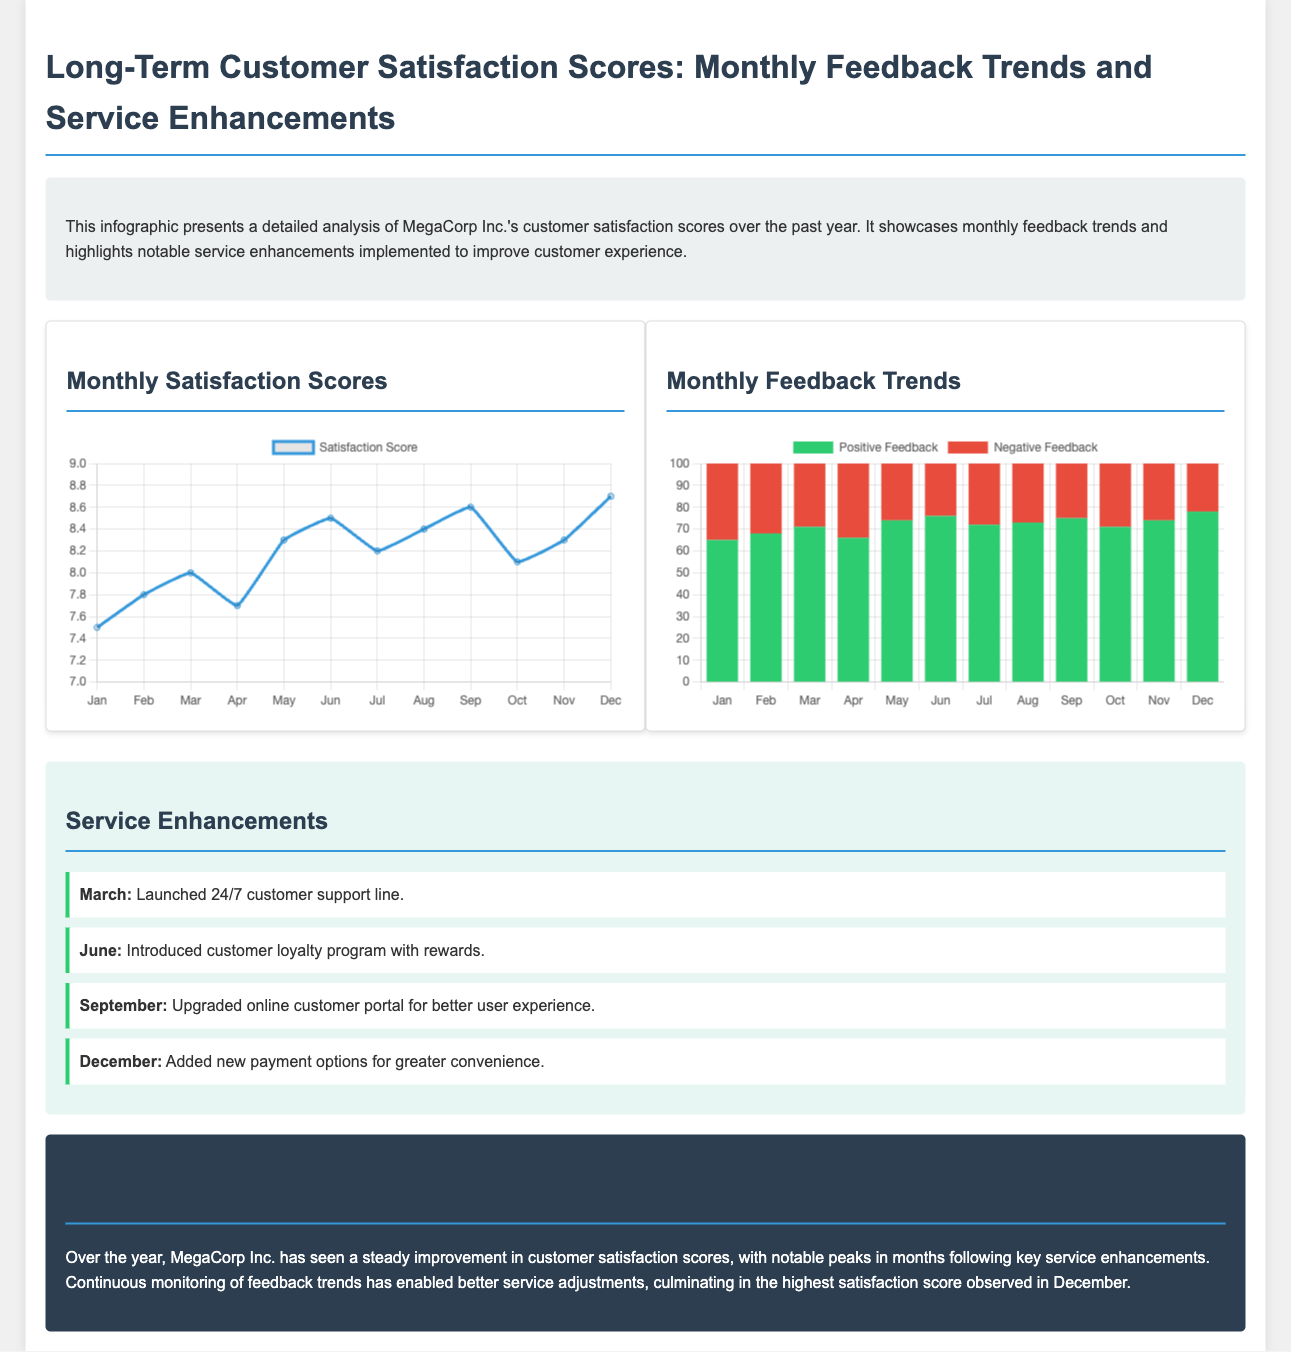What was the highest satisfaction score recorded? The highest satisfaction score recorded in December was 8.7.
Answer: 8.7 When was the 24/7 customer support line launched? The 24/7 customer support line was launched in March.
Answer: March What was the satisfaction score in June? The satisfaction score in June was 8.5.
Answer: 8.5 Which month saw the introduction of the customer loyalty program? The customer loyalty program was introduced in June.
Answer: June What is the maximum possible score shown in the satisfaction chart? The maximum possible score shown in the satisfaction chart is 9.
Answer: 9 How much positive feedback was received in February? In February, 68 positive feedback entries were received.
Answer: 68 What notable service enhancement occurred in September? In September, the online customer portal was upgraded for better user experience.
Answer: Upgraded online customer portal Which month had the lowest negative feedback? The month with the lowest negative feedback was December, with 22 entries.
Answer: December 